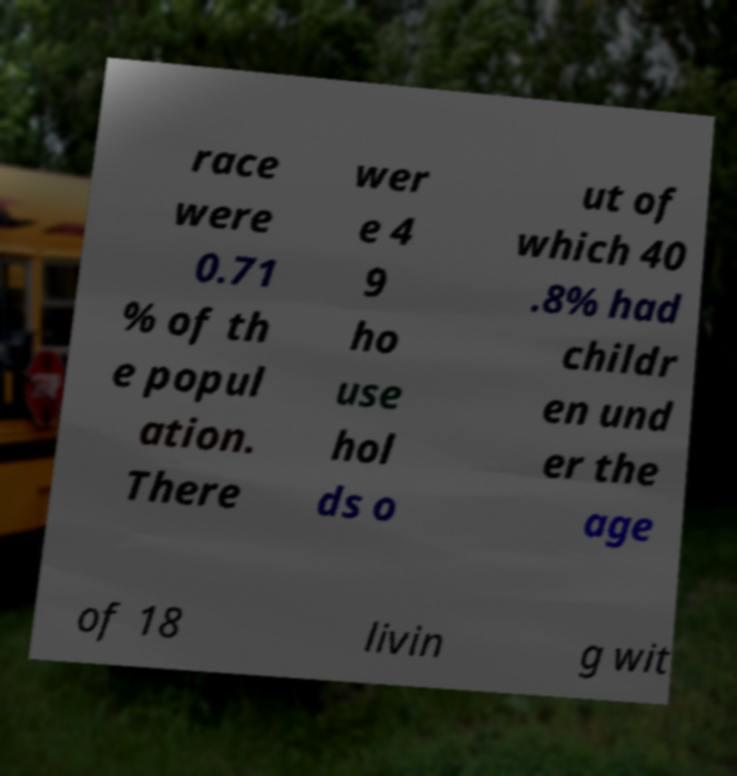I need the written content from this picture converted into text. Can you do that? race were 0.71 % of th e popul ation. There wer e 4 9 ho use hol ds o ut of which 40 .8% had childr en und er the age of 18 livin g wit 